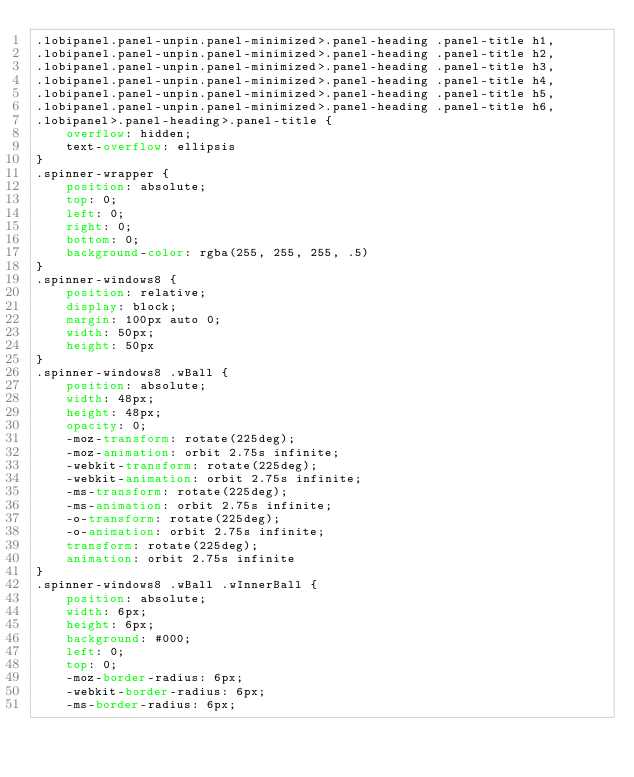<code> <loc_0><loc_0><loc_500><loc_500><_CSS_>.lobipanel.panel-unpin.panel-minimized>.panel-heading .panel-title h1,
.lobipanel.panel-unpin.panel-minimized>.panel-heading .panel-title h2,
.lobipanel.panel-unpin.panel-minimized>.panel-heading .panel-title h3,
.lobipanel.panel-unpin.panel-minimized>.panel-heading .panel-title h4,
.lobipanel.panel-unpin.panel-minimized>.panel-heading .panel-title h5,
.lobipanel.panel-unpin.panel-minimized>.panel-heading .panel-title h6,
.lobipanel>.panel-heading>.panel-title {
    overflow: hidden;
    text-overflow: ellipsis
}
.spinner-wrapper {
    position: absolute;
    top: 0;
    left: 0;
    right: 0;
    bottom: 0;
    background-color: rgba(255, 255, 255, .5)
}
.spinner-windows8 {
    position: relative;
    display: block;
    margin: 100px auto 0;
    width: 50px;
    height: 50px
}
.spinner-windows8 .wBall {
    position: absolute;
    width: 48px;
    height: 48px;
    opacity: 0;
    -moz-transform: rotate(225deg);
    -moz-animation: orbit 2.75s infinite;
    -webkit-transform: rotate(225deg);
    -webkit-animation: orbit 2.75s infinite;
    -ms-transform: rotate(225deg);
    -ms-animation: orbit 2.75s infinite;
    -o-transform: rotate(225deg);
    -o-animation: orbit 2.75s infinite;
    transform: rotate(225deg);
    animation: orbit 2.75s infinite
}
.spinner-windows8 .wBall .wInnerBall {
    position: absolute;
    width: 6px;
    height: 6px;
    background: #000;
    left: 0;
    top: 0;
    -moz-border-radius: 6px;
    -webkit-border-radius: 6px;
    -ms-border-radius: 6px;</code> 